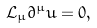<formula> <loc_0><loc_0><loc_500><loc_500>\mathcal { L } _ { \mu } \partial ^ { \mu } u = 0 ,</formula> 